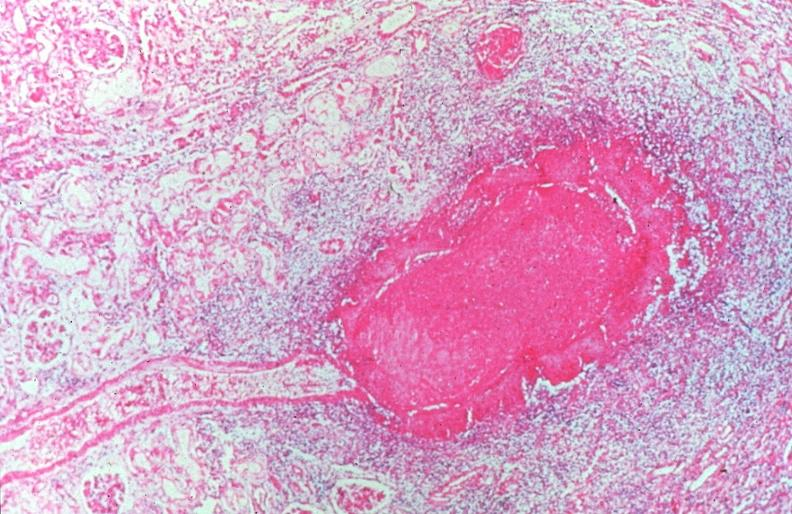s situs inversus present?
Answer the question using a single word or phrase. No 